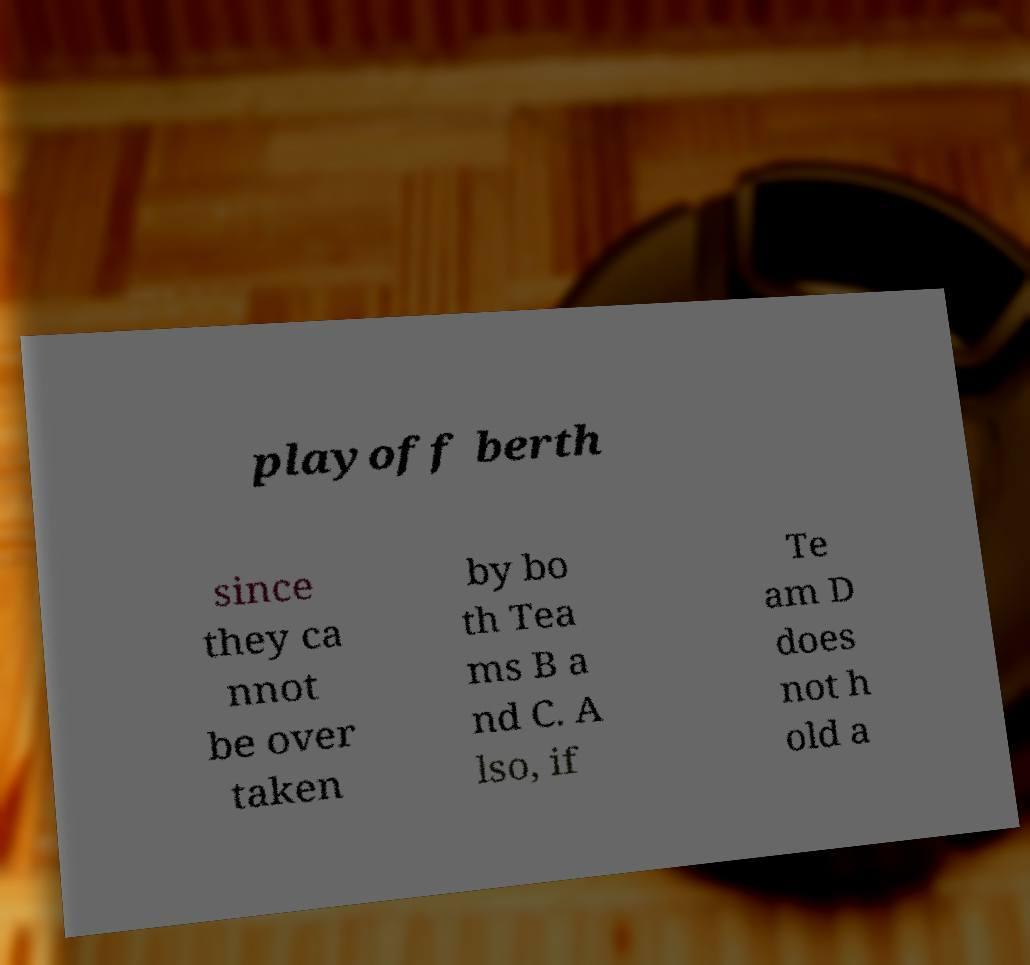Could you extract and type out the text from this image? playoff berth since they ca nnot be over taken by bo th Tea ms B a nd C. A lso, if Te am D does not h old a 